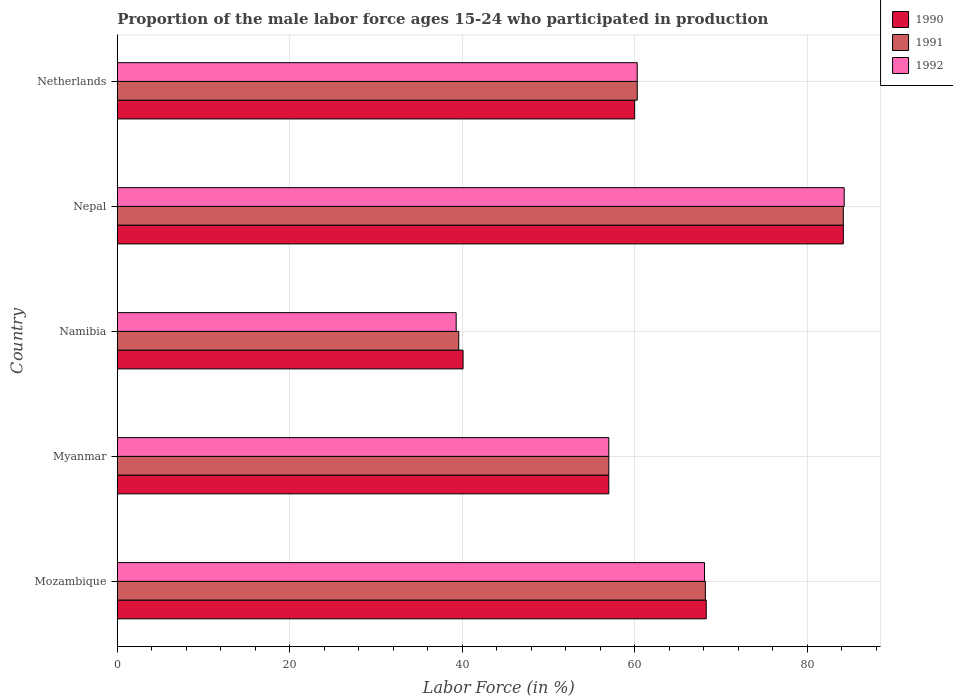Are the number of bars on each tick of the Y-axis equal?
Ensure brevity in your answer.  Yes. How many bars are there on the 3rd tick from the top?
Make the answer very short. 3. What is the proportion of the male labor force who participated in production in 1992 in Netherlands?
Keep it short and to the point. 60.3. Across all countries, what is the maximum proportion of the male labor force who participated in production in 1990?
Your answer should be compact. 84.2. Across all countries, what is the minimum proportion of the male labor force who participated in production in 1992?
Offer a very short reply. 39.3. In which country was the proportion of the male labor force who participated in production in 1990 maximum?
Ensure brevity in your answer.  Nepal. In which country was the proportion of the male labor force who participated in production in 1991 minimum?
Make the answer very short. Namibia. What is the total proportion of the male labor force who participated in production in 1991 in the graph?
Make the answer very short. 309.3. What is the difference between the proportion of the male labor force who participated in production in 1990 in Mozambique and that in Nepal?
Ensure brevity in your answer.  -15.9. What is the difference between the proportion of the male labor force who participated in production in 1991 in Namibia and the proportion of the male labor force who participated in production in 1992 in Mozambique?
Provide a short and direct response. -28.5. What is the average proportion of the male labor force who participated in production in 1990 per country?
Provide a short and direct response. 61.92. What is the difference between the proportion of the male labor force who participated in production in 1992 and proportion of the male labor force who participated in production in 1991 in Nepal?
Provide a succinct answer. 0.1. In how many countries, is the proportion of the male labor force who participated in production in 1990 greater than 24 %?
Give a very brief answer. 5. What is the ratio of the proportion of the male labor force who participated in production in 1992 in Namibia to that in Netherlands?
Offer a terse response. 0.65. Is the proportion of the male labor force who participated in production in 1992 in Nepal less than that in Netherlands?
Your answer should be compact. No. What is the difference between the highest and the second highest proportion of the male labor force who participated in production in 1992?
Your response must be concise. 16.2. What is the difference between the highest and the lowest proportion of the male labor force who participated in production in 1991?
Your answer should be compact. 44.6. In how many countries, is the proportion of the male labor force who participated in production in 1990 greater than the average proportion of the male labor force who participated in production in 1990 taken over all countries?
Offer a very short reply. 2. Is the sum of the proportion of the male labor force who participated in production in 1992 in Mozambique and Namibia greater than the maximum proportion of the male labor force who participated in production in 1991 across all countries?
Give a very brief answer. Yes. What does the 1st bar from the top in Nepal represents?
Provide a succinct answer. 1992. What does the 2nd bar from the bottom in Namibia represents?
Offer a very short reply. 1991. Are all the bars in the graph horizontal?
Keep it short and to the point. Yes. How many countries are there in the graph?
Make the answer very short. 5. What is the difference between two consecutive major ticks on the X-axis?
Provide a succinct answer. 20. Are the values on the major ticks of X-axis written in scientific E-notation?
Your answer should be compact. No. Does the graph contain any zero values?
Your answer should be compact. No. Where does the legend appear in the graph?
Your response must be concise. Top right. How many legend labels are there?
Provide a short and direct response. 3. How are the legend labels stacked?
Ensure brevity in your answer.  Vertical. What is the title of the graph?
Make the answer very short. Proportion of the male labor force ages 15-24 who participated in production. Does "1986" appear as one of the legend labels in the graph?
Your response must be concise. No. What is the label or title of the Y-axis?
Give a very brief answer. Country. What is the Labor Force (in %) of 1990 in Mozambique?
Make the answer very short. 68.3. What is the Labor Force (in %) of 1991 in Mozambique?
Offer a terse response. 68.2. What is the Labor Force (in %) of 1992 in Mozambique?
Provide a short and direct response. 68.1. What is the Labor Force (in %) in 1990 in Myanmar?
Your answer should be very brief. 57. What is the Labor Force (in %) in 1990 in Namibia?
Your response must be concise. 40.1. What is the Labor Force (in %) in 1991 in Namibia?
Ensure brevity in your answer.  39.6. What is the Labor Force (in %) of 1992 in Namibia?
Keep it short and to the point. 39.3. What is the Labor Force (in %) in 1990 in Nepal?
Ensure brevity in your answer.  84.2. What is the Labor Force (in %) of 1991 in Nepal?
Your response must be concise. 84.2. What is the Labor Force (in %) of 1992 in Nepal?
Offer a very short reply. 84.3. What is the Labor Force (in %) in 1991 in Netherlands?
Ensure brevity in your answer.  60.3. What is the Labor Force (in %) of 1992 in Netherlands?
Make the answer very short. 60.3. Across all countries, what is the maximum Labor Force (in %) of 1990?
Offer a very short reply. 84.2. Across all countries, what is the maximum Labor Force (in %) in 1991?
Your response must be concise. 84.2. Across all countries, what is the maximum Labor Force (in %) of 1992?
Make the answer very short. 84.3. Across all countries, what is the minimum Labor Force (in %) of 1990?
Provide a succinct answer. 40.1. Across all countries, what is the minimum Labor Force (in %) in 1991?
Make the answer very short. 39.6. Across all countries, what is the minimum Labor Force (in %) of 1992?
Give a very brief answer. 39.3. What is the total Labor Force (in %) in 1990 in the graph?
Ensure brevity in your answer.  309.6. What is the total Labor Force (in %) in 1991 in the graph?
Give a very brief answer. 309.3. What is the total Labor Force (in %) of 1992 in the graph?
Give a very brief answer. 309. What is the difference between the Labor Force (in %) in 1990 in Mozambique and that in Myanmar?
Offer a very short reply. 11.3. What is the difference between the Labor Force (in %) in 1991 in Mozambique and that in Myanmar?
Provide a short and direct response. 11.2. What is the difference between the Labor Force (in %) of 1992 in Mozambique and that in Myanmar?
Your response must be concise. 11.1. What is the difference between the Labor Force (in %) of 1990 in Mozambique and that in Namibia?
Offer a very short reply. 28.2. What is the difference between the Labor Force (in %) in 1991 in Mozambique and that in Namibia?
Your answer should be compact. 28.6. What is the difference between the Labor Force (in %) in 1992 in Mozambique and that in Namibia?
Keep it short and to the point. 28.8. What is the difference between the Labor Force (in %) of 1990 in Mozambique and that in Nepal?
Offer a very short reply. -15.9. What is the difference between the Labor Force (in %) in 1992 in Mozambique and that in Nepal?
Your answer should be very brief. -16.2. What is the difference between the Labor Force (in %) in 1990 in Mozambique and that in Netherlands?
Provide a short and direct response. 8.3. What is the difference between the Labor Force (in %) of 1990 in Myanmar and that in Namibia?
Provide a short and direct response. 16.9. What is the difference between the Labor Force (in %) in 1992 in Myanmar and that in Namibia?
Ensure brevity in your answer.  17.7. What is the difference between the Labor Force (in %) in 1990 in Myanmar and that in Nepal?
Give a very brief answer. -27.2. What is the difference between the Labor Force (in %) in 1991 in Myanmar and that in Nepal?
Your response must be concise. -27.2. What is the difference between the Labor Force (in %) of 1992 in Myanmar and that in Nepal?
Your response must be concise. -27.3. What is the difference between the Labor Force (in %) in 1991 in Myanmar and that in Netherlands?
Provide a succinct answer. -3.3. What is the difference between the Labor Force (in %) in 1990 in Namibia and that in Nepal?
Provide a succinct answer. -44.1. What is the difference between the Labor Force (in %) in 1991 in Namibia and that in Nepal?
Offer a terse response. -44.6. What is the difference between the Labor Force (in %) of 1992 in Namibia and that in Nepal?
Ensure brevity in your answer.  -45. What is the difference between the Labor Force (in %) of 1990 in Namibia and that in Netherlands?
Your answer should be compact. -19.9. What is the difference between the Labor Force (in %) of 1991 in Namibia and that in Netherlands?
Give a very brief answer. -20.7. What is the difference between the Labor Force (in %) of 1990 in Nepal and that in Netherlands?
Your response must be concise. 24.2. What is the difference between the Labor Force (in %) of 1991 in Nepal and that in Netherlands?
Your response must be concise. 23.9. What is the difference between the Labor Force (in %) in 1990 in Mozambique and the Labor Force (in %) in 1991 in Myanmar?
Give a very brief answer. 11.3. What is the difference between the Labor Force (in %) of 1990 in Mozambique and the Labor Force (in %) of 1992 in Myanmar?
Make the answer very short. 11.3. What is the difference between the Labor Force (in %) in 1990 in Mozambique and the Labor Force (in %) in 1991 in Namibia?
Offer a very short reply. 28.7. What is the difference between the Labor Force (in %) of 1990 in Mozambique and the Labor Force (in %) of 1992 in Namibia?
Make the answer very short. 29. What is the difference between the Labor Force (in %) of 1991 in Mozambique and the Labor Force (in %) of 1992 in Namibia?
Provide a succinct answer. 28.9. What is the difference between the Labor Force (in %) in 1990 in Mozambique and the Labor Force (in %) in 1991 in Nepal?
Ensure brevity in your answer.  -15.9. What is the difference between the Labor Force (in %) of 1990 in Mozambique and the Labor Force (in %) of 1992 in Nepal?
Give a very brief answer. -16. What is the difference between the Labor Force (in %) in 1991 in Mozambique and the Labor Force (in %) in 1992 in Nepal?
Give a very brief answer. -16.1. What is the difference between the Labor Force (in %) of 1990 in Mozambique and the Labor Force (in %) of 1992 in Netherlands?
Your answer should be compact. 8. What is the difference between the Labor Force (in %) in 1990 in Myanmar and the Labor Force (in %) in 1992 in Namibia?
Offer a terse response. 17.7. What is the difference between the Labor Force (in %) of 1990 in Myanmar and the Labor Force (in %) of 1991 in Nepal?
Give a very brief answer. -27.2. What is the difference between the Labor Force (in %) in 1990 in Myanmar and the Labor Force (in %) in 1992 in Nepal?
Provide a succinct answer. -27.3. What is the difference between the Labor Force (in %) of 1991 in Myanmar and the Labor Force (in %) of 1992 in Nepal?
Provide a succinct answer. -27.3. What is the difference between the Labor Force (in %) of 1990 in Myanmar and the Labor Force (in %) of 1991 in Netherlands?
Make the answer very short. -3.3. What is the difference between the Labor Force (in %) in 1990 in Myanmar and the Labor Force (in %) in 1992 in Netherlands?
Your response must be concise. -3.3. What is the difference between the Labor Force (in %) of 1990 in Namibia and the Labor Force (in %) of 1991 in Nepal?
Make the answer very short. -44.1. What is the difference between the Labor Force (in %) of 1990 in Namibia and the Labor Force (in %) of 1992 in Nepal?
Offer a very short reply. -44.2. What is the difference between the Labor Force (in %) in 1991 in Namibia and the Labor Force (in %) in 1992 in Nepal?
Ensure brevity in your answer.  -44.7. What is the difference between the Labor Force (in %) in 1990 in Namibia and the Labor Force (in %) in 1991 in Netherlands?
Ensure brevity in your answer.  -20.2. What is the difference between the Labor Force (in %) in 1990 in Namibia and the Labor Force (in %) in 1992 in Netherlands?
Keep it short and to the point. -20.2. What is the difference between the Labor Force (in %) of 1991 in Namibia and the Labor Force (in %) of 1992 in Netherlands?
Make the answer very short. -20.7. What is the difference between the Labor Force (in %) in 1990 in Nepal and the Labor Force (in %) in 1991 in Netherlands?
Provide a succinct answer. 23.9. What is the difference between the Labor Force (in %) of 1990 in Nepal and the Labor Force (in %) of 1992 in Netherlands?
Provide a short and direct response. 23.9. What is the difference between the Labor Force (in %) of 1991 in Nepal and the Labor Force (in %) of 1992 in Netherlands?
Provide a short and direct response. 23.9. What is the average Labor Force (in %) in 1990 per country?
Ensure brevity in your answer.  61.92. What is the average Labor Force (in %) in 1991 per country?
Your answer should be very brief. 61.86. What is the average Labor Force (in %) in 1992 per country?
Your answer should be very brief. 61.8. What is the difference between the Labor Force (in %) in 1990 and Labor Force (in %) in 1991 in Mozambique?
Your answer should be compact. 0.1. What is the difference between the Labor Force (in %) of 1991 and Labor Force (in %) of 1992 in Mozambique?
Keep it short and to the point. 0.1. What is the difference between the Labor Force (in %) of 1990 and Labor Force (in %) of 1991 in Myanmar?
Your answer should be very brief. 0. What is the difference between the Labor Force (in %) of 1990 and Labor Force (in %) of 1992 in Nepal?
Your answer should be compact. -0.1. What is the difference between the Labor Force (in %) of 1990 and Labor Force (in %) of 1991 in Netherlands?
Give a very brief answer. -0.3. What is the difference between the Labor Force (in %) in 1991 and Labor Force (in %) in 1992 in Netherlands?
Offer a very short reply. 0. What is the ratio of the Labor Force (in %) of 1990 in Mozambique to that in Myanmar?
Make the answer very short. 1.2. What is the ratio of the Labor Force (in %) of 1991 in Mozambique to that in Myanmar?
Provide a short and direct response. 1.2. What is the ratio of the Labor Force (in %) in 1992 in Mozambique to that in Myanmar?
Offer a terse response. 1.19. What is the ratio of the Labor Force (in %) in 1990 in Mozambique to that in Namibia?
Keep it short and to the point. 1.7. What is the ratio of the Labor Force (in %) of 1991 in Mozambique to that in Namibia?
Provide a succinct answer. 1.72. What is the ratio of the Labor Force (in %) of 1992 in Mozambique to that in Namibia?
Your answer should be compact. 1.73. What is the ratio of the Labor Force (in %) of 1990 in Mozambique to that in Nepal?
Provide a short and direct response. 0.81. What is the ratio of the Labor Force (in %) in 1991 in Mozambique to that in Nepal?
Give a very brief answer. 0.81. What is the ratio of the Labor Force (in %) of 1992 in Mozambique to that in Nepal?
Provide a short and direct response. 0.81. What is the ratio of the Labor Force (in %) of 1990 in Mozambique to that in Netherlands?
Make the answer very short. 1.14. What is the ratio of the Labor Force (in %) of 1991 in Mozambique to that in Netherlands?
Make the answer very short. 1.13. What is the ratio of the Labor Force (in %) of 1992 in Mozambique to that in Netherlands?
Give a very brief answer. 1.13. What is the ratio of the Labor Force (in %) in 1990 in Myanmar to that in Namibia?
Make the answer very short. 1.42. What is the ratio of the Labor Force (in %) of 1991 in Myanmar to that in Namibia?
Keep it short and to the point. 1.44. What is the ratio of the Labor Force (in %) in 1992 in Myanmar to that in Namibia?
Make the answer very short. 1.45. What is the ratio of the Labor Force (in %) of 1990 in Myanmar to that in Nepal?
Give a very brief answer. 0.68. What is the ratio of the Labor Force (in %) in 1991 in Myanmar to that in Nepal?
Make the answer very short. 0.68. What is the ratio of the Labor Force (in %) of 1992 in Myanmar to that in Nepal?
Your answer should be compact. 0.68. What is the ratio of the Labor Force (in %) in 1990 in Myanmar to that in Netherlands?
Your answer should be very brief. 0.95. What is the ratio of the Labor Force (in %) in 1991 in Myanmar to that in Netherlands?
Ensure brevity in your answer.  0.95. What is the ratio of the Labor Force (in %) in 1992 in Myanmar to that in Netherlands?
Keep it short and to the point. 0.95. What is the ratio of the Labor Force (in %) in 1990 in Namibia to that in Nepal?
Offer a terse response. 0.48. What is the ratio of the Labor Force (in %) in 1991 in Namibia to that in Nepal?
Offer a very short reply. 0.47. What is the ratio of the Labor Force (in %) in 1992 in Namibia to that in Nepal?
Give a very brief answer. 0.47. What is the ratio of the Labor Force (in %) in 1990 in Namibia to that in Netherlands?
Give a very brief answer. 0.67. What is the ratio of the Labor Force (in %) in 1991 in Namibia to that in Netherlands?
Keep it short and to the point. 0.66. What is the ratio of the Labor Force (in %) in 1992 in Namibia to that in Netherlands?
Your answer should be very brief. 0.65. What is the ratio of the Labor Force (in %) of 1990 in Nepal to that in Netherlands?
Your answer should be compact. 1.4. What is the ratio of the Labor Force (in %) of 1991 in Nepal to that in Netherlands?
Offer a very short reply. 1.4. What is the ratio of the Labor Force (in %) of 1992 in Nepal to that in Netherlands?
Give a very brief answer. 1.4. What is the difference between the highest and the second highest Labor Force (in %) in 1990?
Make the answer very short. 15.9. What is the difference between the highest and the second highest Labor Force (in %) of 1991?
Offer a terse response. 16. What is the difference between the highest and the lowest Labor Force (in %) of 1990?
Ensure brevity in your answer.  44.1. What is the difference between the highest and the lowest Labor Force (in %) of 1991?
Ensure brevity in your answer.  44.6. What is the difference between the highest and the lowest Labor Force (in %) of 1992?
Offer a very short reply. 45. 